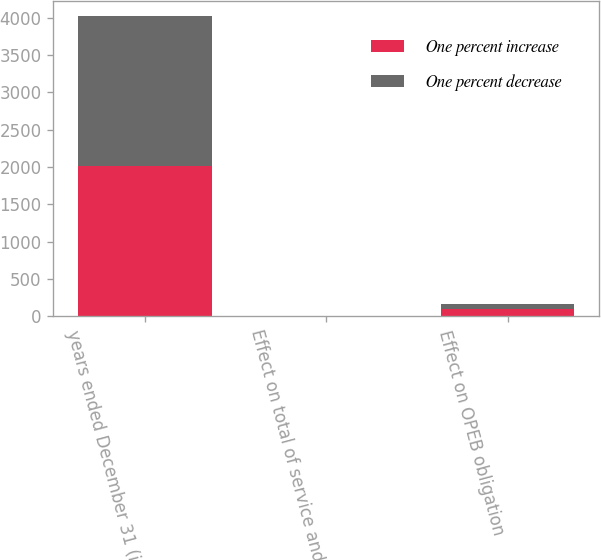Convert chart. <chart><loc_0><loc_0><loc_500><loc_500><stacked_bar_chart><ecel><fcel>years ended December 31 (in<fcel>Effect on total of service and<fcel>Effect on OPEB obligation<nl><fcel>One percent increase<fcel>2012<fcel>5<fcel>92<nl><fcel>One percent decrease<fcel>2012<fcel>4<fcel>74<nl></chart> 